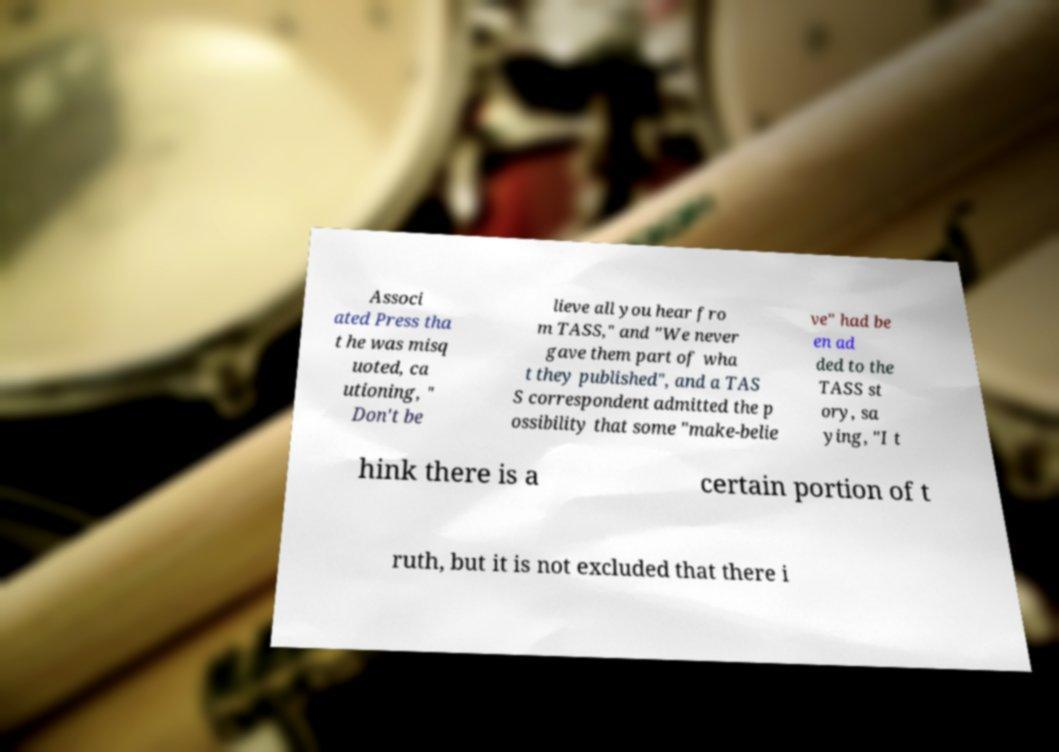Can you accurately transcribe the text from the provided image for me? Associ ated Press tha t he was misq uoted, ca utioning, " Don't be lieve all you hear fro m TASS," and "We never gave them part of wha t they published", and a TAS S correspondent admitted the p ossibility that some "make-belie ve" had be en ad ded to the TASS st ory, sa ying, "I t hink there is a certain portion of t ruth, but it is not excluded that there i 